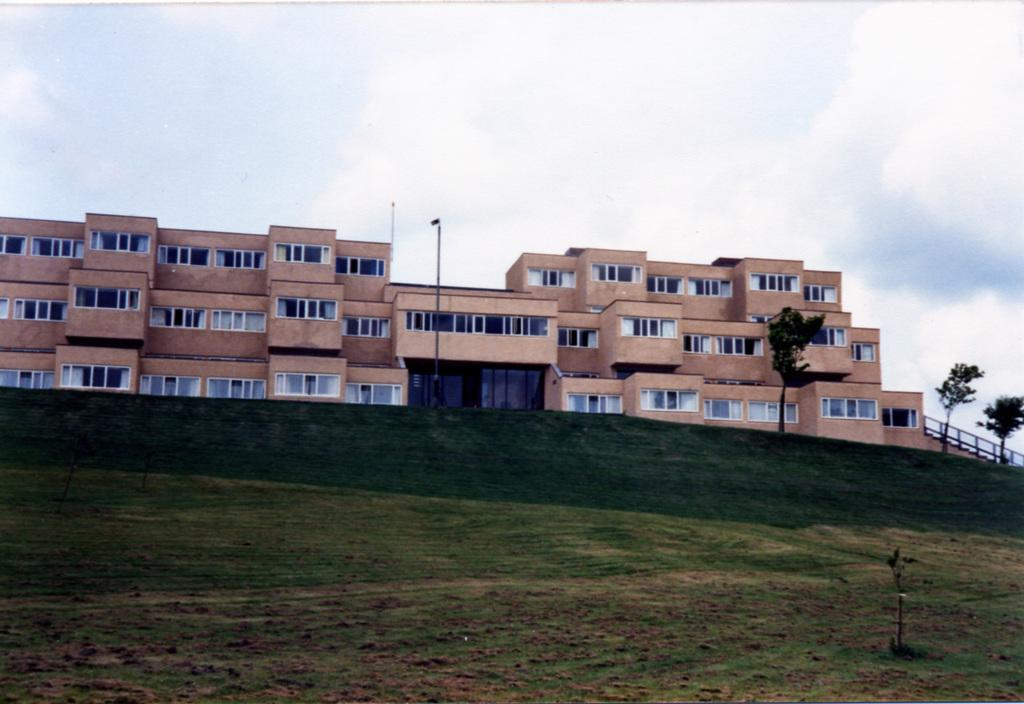What type of structure is present in the image? There is a building in the image. What feature can be seen on the building? The building has windows. What type of vegetation is visible in the image? There are trees in the image. What else can be seen in the image besides the building and trees? There are poles and grass visible in the image. How would you describe the weather in the image? The sky is cloudy in the image. Where is the library located in the image? There is no library mentioned or visible in the image. Can you see any snakes in the image? There are no snakes present in the image. 